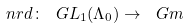Convert formula to latex. <formula><loc_0><loc_0><loc_500><loc_500>\ n r d \colon \ G L _ { 1 } ( \Lambda _ { 0 } ) \to \ G m</formula> 